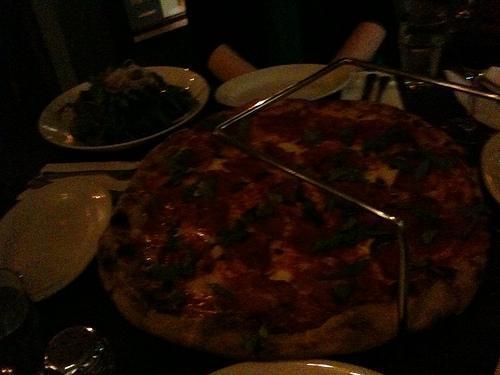How many pizzas are there?
Give a very brief answer. 1. How many cups are in the photo?
Give a very brief answer. 2. How many bowls can you see?
Give a very brief answer. 2. How many pizzas are there?
Give a very brief answer. 1. How many toilets are there?
Give a very brief answer. 0. 